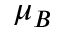Convert formula to latex. <formula><loc_0><loc_0><loc_500><loc_500>\mu { _ { B } }</formula> 